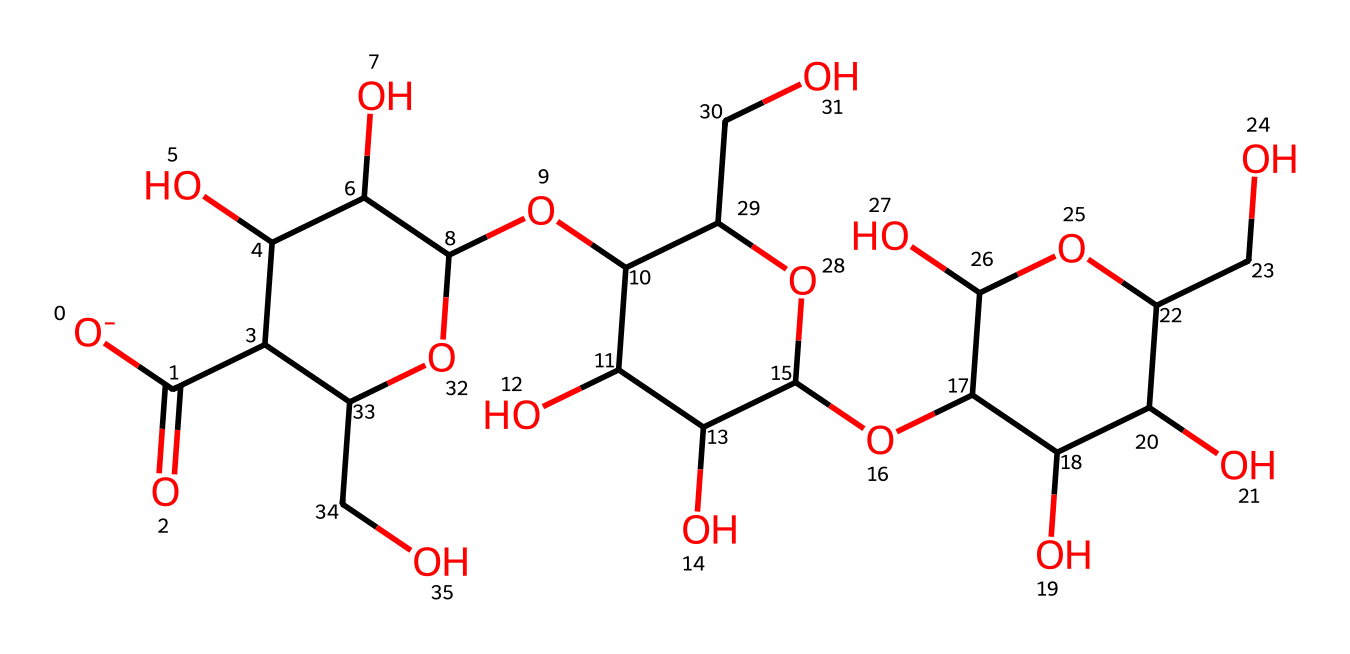What is the primary building block of this chemical? The primary building block of cellulose is glucose, as evident from the repeating sugar units indicated in the structure.
Answer: glucose How many oxygen atoms are present in this chemical structure? By examining the SMILES representation, we can count the oxygen atoms. There are 6 oxygen atoms present in the structure.
Answer: 6 What type of polymer is cellulose classified as? Cellulose is classified as a polysaccharide due to its composition of multiple sugar units linked together.
Answer: polysaccharide What is the significance of the hydroxyl (-OH) groups in this chemical? Hydroxyl groups provide cellulose with hydrophilicity, allowing it to interact with water, which is crucial for its properties in fibers.
Answer: hydrophilicity How many rings are present in this chemical structure? By analyzing the structure, we can see there are three cyclic glucose units in the cellulose polymer.
Answer: 3 What functional groups are mainly present in the chemical structure of cellulose? The main functional group in cellulose is the hydroxyl (-OH) group, contributing to its reactive properties and solubility.
Answer: hydroxyl groups 